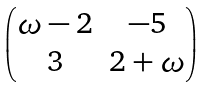<formula> <loc_0><loc_0><loc_500><loc_500>\begin{pmatrix} \omega - 2 & - 5 \\ 3 & 2 + \omega \end{pmatrix}</formula> 